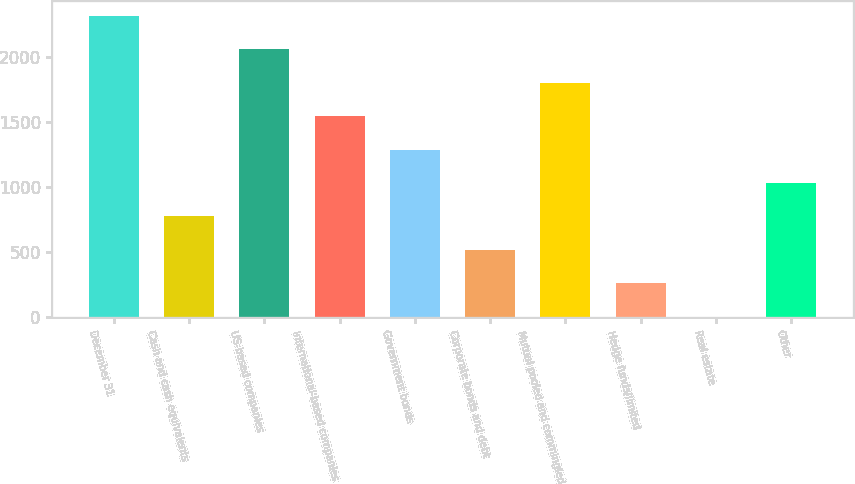Convert chart. <chart><loc_0><loc_0><loc_500><loc_500><bar_chart><fcel>December 31<fcel>Cash and cash equivalents<fcel>US-based companies<fcel>International-based companies<fcel>Government bonds<fcel>Corporate bonds and debt<fcel>Mutual pooled and commingled<fcel>Hedge funds/limited<fcel>Real estate<fcel>Other<nl><fcel>2310.9<fcel>774.3<fcel>2054.8<fcel>1542.6<fcel>1286.5<fcel>518.2<fcel>1798.7<fcel>262.1<fcel>6<fcel>1030.4<nl></chart> 